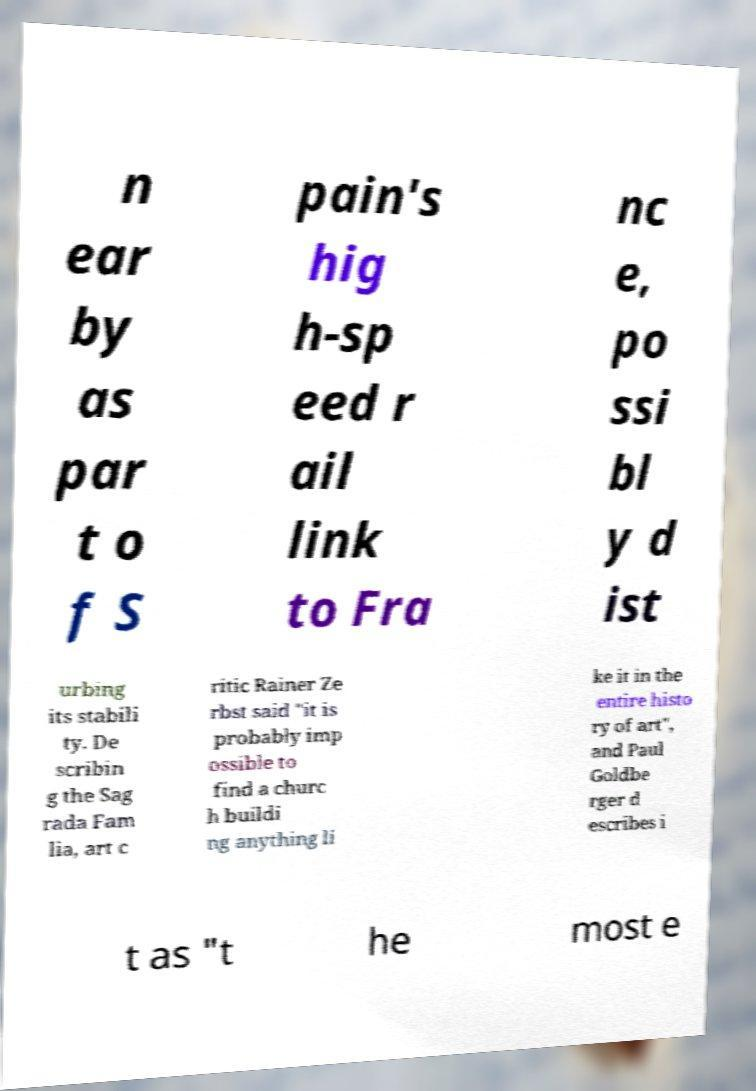Please read and relay the text visible in this image. What does it say? n ear by as par t o f S pain's hig h-sp eed r ail link to Fra nc e, po ssi bl y d ist urbing its stabili ty. De scribin g the Sag rada Fam lia, art c ritic Rainer Ze rbst said "it is probably imp ossible to find a churc h buildi ng anything li ke it in the entire histo ry of art", and Paul Goldbe rger d escribes i t as "t he most e 